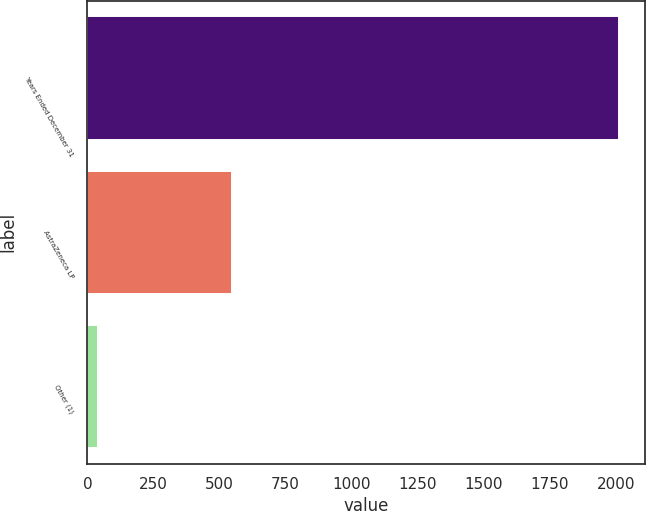Convert chart. <chart><loc_0><loc_0><loc_500><loc_500><bar_chart><fcel>Years Ended December 31<fcel>AstraZeneca LP<fcel>Other (1)<nl><fcel>2010<fcel>546<fcel>41<nl></chart> 